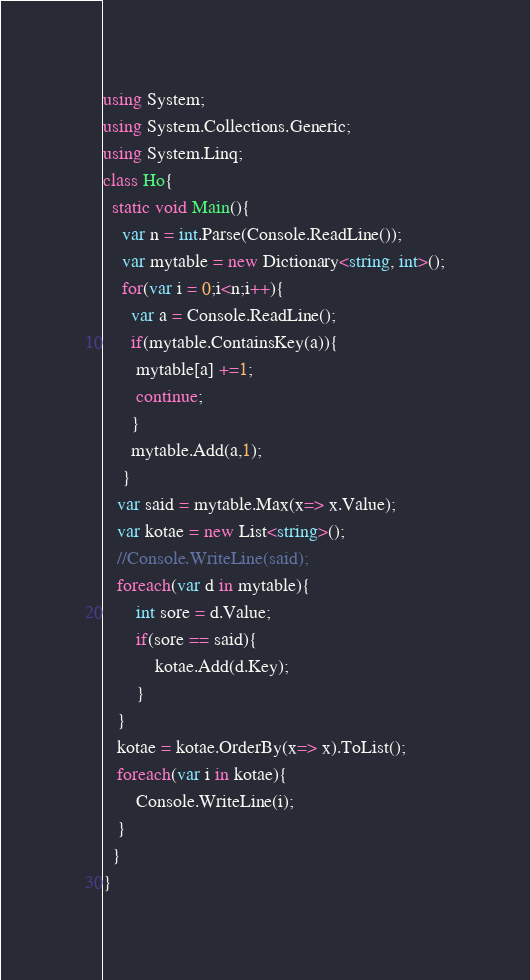<code> <loc_0><loc_0><loc_500><loc_500><_C#_>using System;
using System.Collections.Generic;
using System.Linq;
class Ho{
  static void Main(){
    var n = int.Parse(Console.ReadLine());
    var mytable = new Dictionary<string, int>();
    for(var i = 0;i<n;i++){
      var a = Console.ReadLine();
      if(mytable.ContainsKey(a)){
       mytable[a] +=1;
       continue;
      }
      mytable.Add(a,1);
    }
   var said = mytable.Max(x=> x.Value);
   var kotae = new List<string>();
   //Console.WriteLine(said);
   foreach(var d in mytable){
       int sore = d.Value;
       if(sore == said){
           kotae.Add(d.Key);
       }
   }
   kotae = kotae.OrderBy(x=> x).ToList();
   foreach(var i in kotae){
       Console.WriteLine(i);
   }
  }
}</code> 